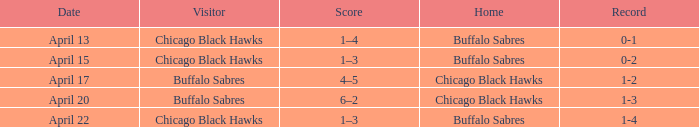Which Score has a Visitor of buffalo sabres and a Record of 1-3? 6–2. 